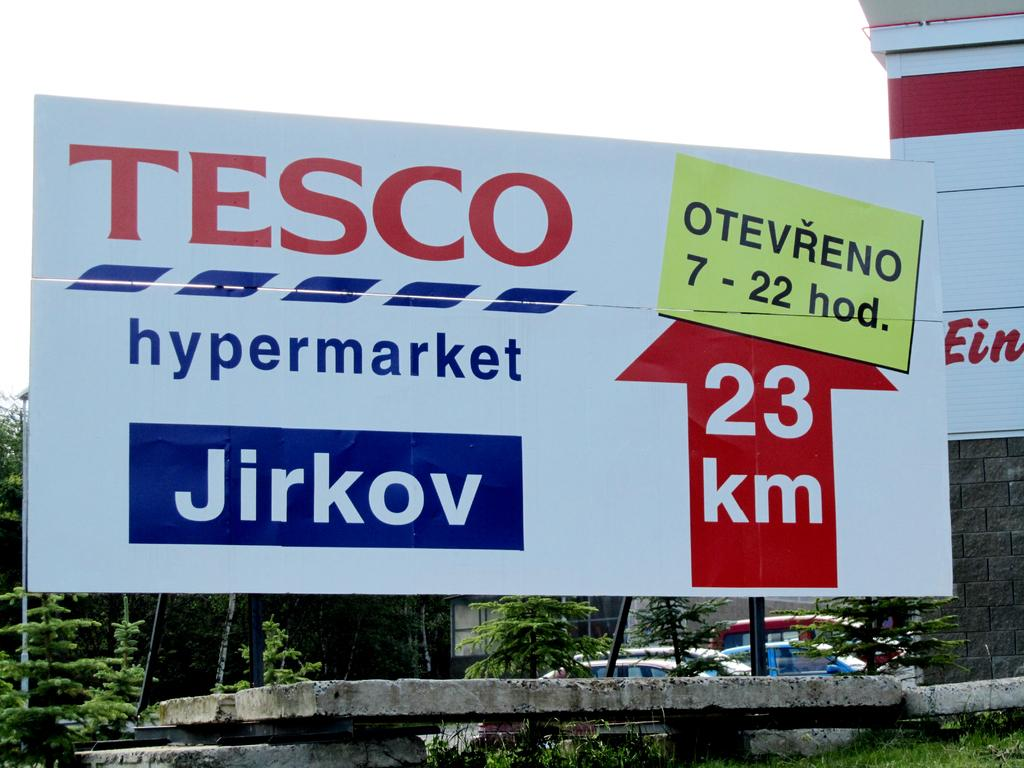<image>
Relay a brief, clear account of the picture shown. A billboard from tesco that says 23 km ahead 